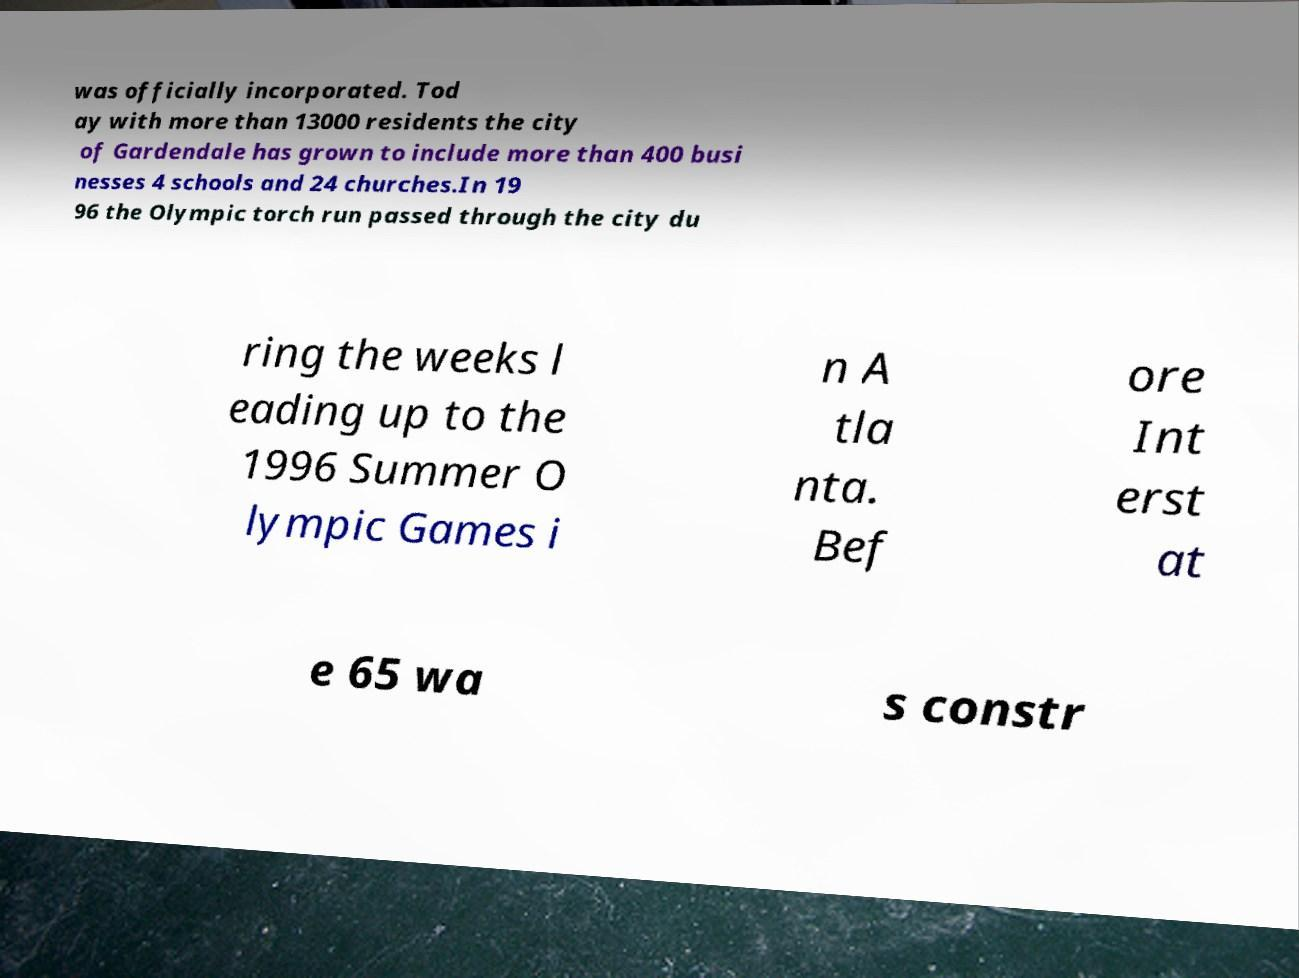Can you read and provide the text displayed in the image?This photo seems to have some interesting text. Can you extract and type it out for me? was officially incorporated. Tod ay with more than 13000 residents the city of Gardendale has grown to include more than 400 busi nesses 4 schools and 24 churches.In 19 96 the Olympic torch run passed through the city du ring the weeks l eading up to the 1996 Summer O lympic Games i n A tla nta. Bef ore Int erst at e 65 wa s constr 